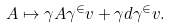Convert formula to latex. <formula><loc_0><loc_0><loc_500><loc_500>A \mapsto \gamma A \gamma ^ { \in } v + \gamma d \gamma ^ { \in } v .</formula> 